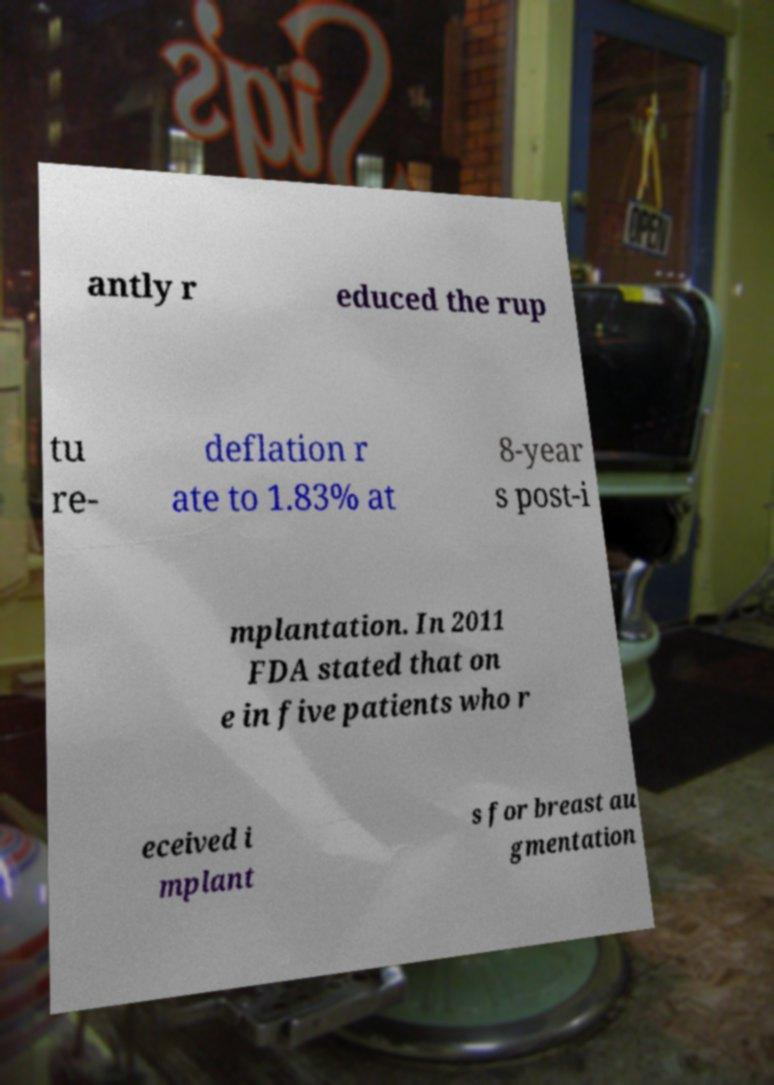Can you read and provide the text displayed in the image?This photo seems to have some interesting text. Can you extract and type it out for me? antly r educed the rup tu re- deflation r ate to 1.83% at 8-year s post-i mplantation. In 2011 FDA stated that on e in five patients who r eceived i mplant s for breast au gmentation 